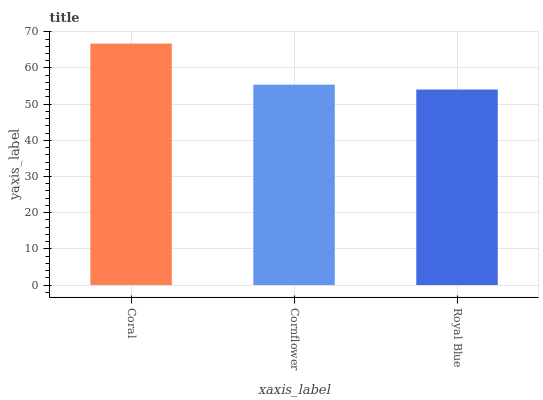Is Royal Blue the minimum?
Answer yes or no. Yes. Is Coral the maximum?
Answer yes or no. Yes. Is Cornflower the minimum?
Answer yes or no. No. Is Cornflower the maximum?
Answer yes or no. No. Is Coral greater than Cornflower?
Answer yes or no. Yes. Is Cornflower less than Coral?
Answer yes or no. Yes. Is Cornflower greater than Coral?
Answer yes or no. No. Is Coral less than Cornflower?
Answer yes or no. No. Is Cornflower the high median?
Answer yes or no. Yes. Is Cornflower the low median?
Answer yes or no. Yes. Is Royal Blue the high median?
Answer yes or no. No. Is Coral the low median?
Answer yes or no. No. 